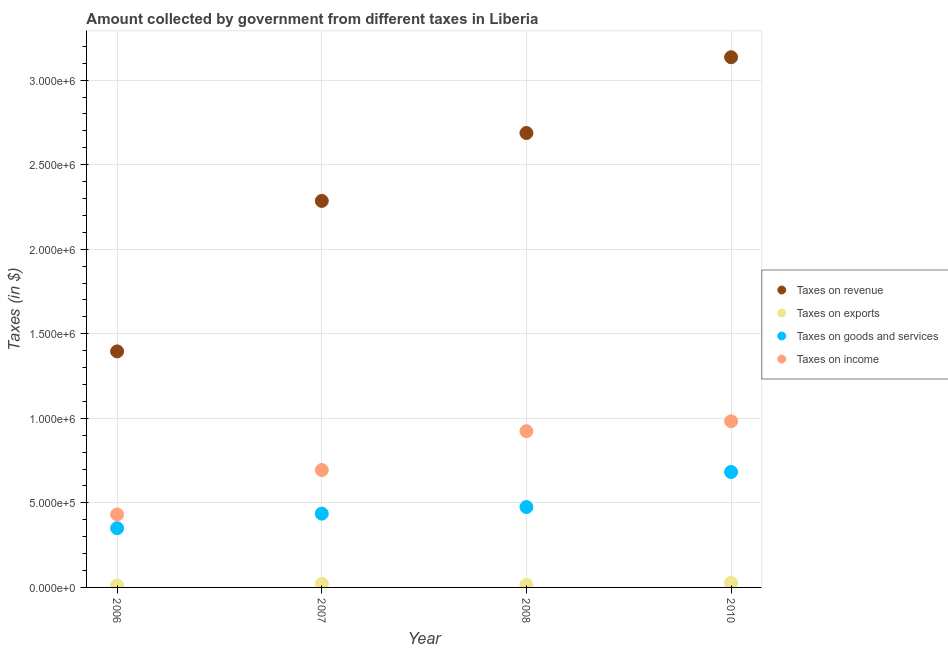How many different coloured dotlines are there?
Give a very brief answer. 4. What is the amount collected as tax on income in 2010?
Offer a terse response. 9.83e+05. Across all years, what is the maximum amount collected as tax on goods?
Provide a succinct answer. 6.83e+05. Across all years, what is the minimum amount collected as tax on revenue?
Give a very brief answer. 1.40e+06. In which year was the amount collected as tax on revenue maximum?
Offer a terse response. 2010. What is the total amount collected as tax on exports in the graph?
Your answer should be very brief. 7.47e+04. What is the difference between the amount collected as tax on income in 2007 and that in 2010?
Offer a very short reply. -2.88e+05. What is the difference between the amount collected as tax on goods in 2010 and the amount collected as tax on revenue in 2006?
Offer a terse response. -7.13e+05. What is the average amount collected as tax on income per year?
Offer a terse response. 7.58e+05. In the year 2010, what is the difference between the amount collected as tax on income and amount collected as tax on revenue?
Keep it short and to the point. -2.15e+06. What is the ratio of the amount collected as tax on exports in 2006 to that in 2010?
Keep it short and to the point. 0.44. Is the amount collected as tax on income in 2008 less than that in 2010?
Make the answer very short. Yes. What is the difference between the highest and the second highest amount collected as tax on exports?
Offer a very short reply. 5566.22. What is the difference between the highest and the lowest amount collected as tax on exports?
Your answer should be very brief. 1.50e+04. In how many years, is the amount collected as tax on goods greater than the average amount collected as tax on goods taken over all years?
Give a very brief answer. 1. Is it the case that in every year, the sum of the amount collected as tax on income and amount collected as tax on exports is greater than the sum of amount collected as tax on goods and amount collected as tax on revenue?
Provide a short and direct response. No. Is it the case that in every year, the sum of the amount collected as tax on revenue and amount collected as tax on exports is greater than the amount collected as tax on goods?
Your response must be concise. Yes. Is the amount collected as tax on income strictly less than the amount collected as tax on exports over the years?
Offer a terse response. No. How many dotlines are there?
Provide a succinct answer. 4. Are the values on the major ticks of Y-axis written in scientific E-notation?
Provide a short and direct response. Yes. Does the graph contain any zero values?
Your response must be concise. No. Does the graph contain grids?
Offer a very short reply. Yes. How many legend labels are there?
Offer a terse response. 4. How are the legend labels stacked?
Keep it short and to the point. Vertical. What is the title of the graph?
Offer a very short reply. Amount collected by government from different taxes in Liberia. What is the label or title of the Y-axis?
Offer a terse response. Taxes (in $). What is the Taxes (in $) of Taxes on revenue in 2006?
Ensure brevity in your answer.  1.40e+06. What is the Taxes (in $) of Taxes on exports in 2006?
Keep it short and to the point. 1.16e+04. What is the Taxes (in $) of Taxes on goods and services in 2006?
Your answer should be compact. 3.50e+05. What is the Taxes (in $) in Taxes on income in 2006?
Give a very brief answer. 4.32e+05. What is the Taxes (in $) in Taxes on revenue in 2007?
Offer a terse response. 2.29e+06. What is the Taxes (in $) in Taxes on exports in 2007?
Make the answer very short. 2.11e+04. What is the Taxes (in $) of Taxes on goods and services in 2007?
Provide a succinct answer. 4.36e+05. What is the Taxes (in $) in Taxes on income in 2007?
Your answer should be compact. 6.94e+05. What is the Taxes (in $) of Taxes on revenue in 2008?
Provide a short and direct response. 2.69e+06. What is the Taxes (in $) in Taxes on exports in 2008?
Ensure brevity in your answer.  1.54e+04. What is the Taxes (in $) of Taxes on goods and services in 2008?
Offer a very short reply. 4.75e+05. What is the Taxes (in $) of Taxes on income in 2008?
Your answer should be very brief. 9.24e+05. What is the Taxes (in $) in Taxes on revenue in 2010?
Offer a very short reply. 3.14e+06. What is the Taxes (in $) in Taxes on exports in 2010?
Ensure brevity in your answer.  2.67e+04. What is the Taxes (in $) of Taxes on goods and services in 2010?
Provide a short and direct response. 6.83e+05. What is the Taxes (in $) of Taxes on income in 2010?
Provide a succinct answer. 9.83e+05. Across all years, what is the maximum Taxes (in $) of Taxes on revenue?
Your answer should be very brief. 3.14e+06. Across all years, what is the maximum Taxes (in $) in Taxes on exports?
Provide a short and direct response. 2.67e+04. Across all years, what is the maximum Taxes (in $) in Taxes on goods and services?
Provide a short and direct response. 6.83e+05. Across all years, what is the maximum Taxes (in $) of Taxes on income?
Your response must be concise. 9.83e+05. Across all years, what is the minimum Taxes (in $) of Taxes on revenue?
Offer a terse response. 1.40e+06. Across all years, what is the minimum Taxes (in $) in Taxes on exports?
Your answer should be very brief. 1.16e+04. Across all years, what is the minimum Taxes (in $) of Taxes on goods and services?
Your answer should be compact. 3.50e+05. Across all years, what is the minimum Taxes (in $) in Taxes on income?
Your answer should be very brief. 4.32e+05. What is the total Taxes (in $) in Taxes on revenue in the graph?
Keep it short and to the point. 9.50e+06. What is the total Taxes (in $) in Taxes on exports in the graph?
Your answer should be compact. 7.47e+04. What is the total Taxes (in $) of Taxes on goods and services in the graph?
Offer a very short reply. 1.94e+06. What is the total Taxes (in $) of Taxes on income in the graph?
Your answer should be very brief. 3.03e+06. What is the difference between the Taxes (in $) in Taxes on revenue in 2006 and that in 2007?
Provide a succinct answer. -8.90e+05. What is the difference between the Taxes (in $) in Taxes on exports in 2006 and that in 2007?
Your response must be concise. -9442.48. What is the difference between the Taxes (in $) in Taxes on goods and services in 2006 and that in 2007?
Provide a short and direct response. -8.60e+04. What is the difference between the Taxes (in $) of Taxes on income in 2006 and that in 2007?
Make the answer very short. -2.63e+05. What is the difference between the Taxes (in $) in Taxes on revenue in 2006 and that in 2008?
Your answer should be very brief. -1.29e+06. What is the difference between the Taxes (in $) of Taxes on exports in 2006 and that in 2008?
Keep it short and to the point. -3711.06. What is the difference between the Taxes (in $) in Taxes on goods and services in 2006 and that in 2008?
Your response must be concise. -1.25e+05. What is the difference between the Taxes (in $) of Taxes on income in 2006 and that in 2008?
Offer a terse response. -4.93e+05. What is the difference between the Taxes (in $) in Taxes on revenue in 2006 and that in 2010?
Your answer should be compact. -1.74e+06. What is the difference between the Taxes (in $) of Taxes on exports in 2006 and that in 2010?
Offer a terse response. -1.50e+04. What is the difference between the Taxes (in $) in Taxes on goods and services in 2006 and that in 2010?
Ensure brevity in your answer.  -3.32e+05. What is the difference between the Taxes (in $) of Taxes on income in 2006 and that in 2010?
Keep it short and to the point. -5.51e+05. What is the difference between the Taxes (in $) of Taxes on revenue in 2007 and that in 2008?
Your response must be concise. -4.02e+05. What is the difference between the Taxes (in $) of Taxes on exports in 2007 and that in 2008?
Provide a short and direct response. 5731.42. What is the difference between the Taxes (in $) of Taxes on goods and services in 2007 and that in 2008?
Provide a succinct answer. -3.91e+04. What is the difference between the Taxes (in $) of Taxes on income in 2007 and that in 2008?
Make the answer very short. -2.30e+05. What is the difference between the Taxes (in $) in Taxes on revenue in 2007 and that in 2010?
Offer a terse response. -8.50e+05. What is the difference between the Taxes (in $) in Taxes on exports in 2007 and that in 2010?
Your response must be concise. -5566.22. What is the difference between the Taxes (in $) of Taxes on goods and services in 2007 and that in 2010?
Your answer should be compact. -2.46e+05. What is the difference between the Taxes (in $) in Taxes on income in 2007 and that in 2010?
Make the answer very short. -2.88e+05. What is the difference between the Taxes (in $) in Taxes on revenue in 2008 and that in 2010?
Provide a succinct answer. -4.48e+05. What is the difference between the Taxes (in $) in Taxes on exports in 2008 and that in 2010?
Your answer should be compact. -1.13e+04. What is the difference between the Taxes (in $) in Taxes on goods and services in 2008 and that in 2010?
Make the answer very short. -2.07e+05. What is the difference between the Taxes (in $) in Taxes on income in 2008 and that in 2010?
Offer a very short reply. -5.85e+04. What is the difference between the Taxes (in $) of Taxes on revenue in 2006 and the Taxes (in $) of Taxes on exports in 2007?
Give a very brief answer. 1.37e+06. What is the difference between the Taxes (in $) of Taxes on revenue in 2006 and the Taxes (in $) of Taxes on goods and services in 2007?
Your answer should be compact. 9.60e+05. What is the difference between the Taxes (in $) of Taxes on revenue in 2006 and the Taxes (in $) of Taxes on income in 2007?
Make the answer very short. 7.01e+05. What is the difference between the Taxes (in $) of Taxes on exports in 2006 and the Taxes (in $) of Taxes on goods and services in 2007?
Provide a succinct answer. -4.25e+05. What is the difference between the Taxes (in $) of Taxes on exports in 2006 and the Taxes (in $) of Taxes on income in 2007?
Provide a succinct answer. -6.83e+05. What is the difference between the Taxes (in $) of Taxes on goods and services in 2006 and the Taxes (in $) of Taxes on income in 2007?
Ensure brevity in your answer.  -3.44e+05. What is the difference between the Taxes (in $) in Taxes on revenue in 2006 and the Taxes (in $) in Taxes on exports in 2008?
Offer a very short reply. 1.38e+06. What is the difference between the Taxes (in $) of Taxes on revenue in 2006 and the Taxes (in $) of Taxes on goods and services in 2008?
Ensure brevity in your answer.  9.20e+05. What is the difference between the Taxes (in $) in Taxes on revenue in 2006 and the Taxes (in $) in Taxes on income in 2008?
Offer a terse response. 4.72e+05. What is the difference between the Taxes (in $) of Taxes on exports in 2006 and the Taxes (in $) of Taxes on goods and services in 2008?
Give a very brief answer. -4.64e+05. What is the difference between the Taxes (in $) in Taxes on exports in 2006 and the Taxes (in $) in Taxes on income in 2008?
Offer a very short reply. -9.12e+05. What is the difference between the Taxes (in $) of Taxes on goods and services in 2006 and the Taxes (in $) of Taxes on income in 2008?
Ensure brevity in your answer.  -5.74e+05. What is the difference between the Taxes (in $) of Taxes on revenue in 2006 and the Taxes (in $) of Taxes on exports in 2010?
Provide a succinct answer. 1.37e+06. What is the difference between the Taxes (in $) in Taxes on revenue in 2006 and the Taxes (in $) in Taxes on goods and services in 2010?
Your answer should be compact. 7.13e+05. What is the difference between the Taxes (in $) in Taxes on revenue in 2006 and the Taxes (in $) in Taxes on income in 2010?
Your answer should be very brief. 4.13e+05. What is the difference between the Taxes (in $) of Taxes on exports in 2006 and the Taxes (in $) of Taxes on goods and services in 2010?
Offer a very short reply. -6.71e+05. What is the difference between the Taxes (in $) of Taxes on exports in 2006 and the Taxes (in $) of Taxes on income in 2010?
Your response must be concise. -9.71e+05. What is the difference between the Taxes (in $) of Taxes on goods and services in 2006 and the Taxes (in $) of Taxes on income in 2010?
Ensure brevity in your answer.  -6.32e+05. What is the difference between the Taxes (in $) of Taxes on revenue in 2007 and the Taxes (in $) of Taxes on exports in 2008?
Make the answer very short. 2.27e+06. What is the difference between the Taxes (in $) in Taxes on revenue in 2007 and the Taxes (in $) in Taxes on goods and services in 2008?
Offer a terse response. 1.81e+06. What is the difference between the Taxes (in $) in Taxes on revenue in 2007 and the Taxes (in $) in Taxes on income in 2008?
Your answer should be compact. 1.36e+06. What is the difference between the Taxes (in $) in Taxes on exports in 2007 and the Taxes (in $) in Taxes on goods and services in 2008?
Give a very brief answer. -4.54e+05. What is the difference between the Taxes (in $) in Taxes on exports in 2007 and the Taxes (in $) in Taxes on income in 2008?
Your answer should be very brief. -9.03e+05. What is the difference between the Taxes (in $) in Taxes on goods and services in 2007 and the Taxes (in $) in Taxes on income in 2008?
Give a very brief answer. -4.88e+05. What is the difference between the Taxes (in $) of Taxes on revenue in 2007 and the Taxes (in $) of Taxes on exports in 2010?
Your response must be concise. 2.26e+06. What is the difference between the Taxes (in $) in Taxes on revenue in 2007 and the Taxes (in $) in Taxes on goods and services in 2010?
Your answer should be compact. 1.60e+06. What is the difference between the Taxes (in $) of Taxes on revenue in 2007 and the Taxes (in $) of Taxes on income in 2010?
Provide a succinct answer. 1.30e+06. What is the difference between the Taxes (in $) in Taxes on exports in 2007 and the Taxes (in $) in Taxes on goods and services in 2010?
Ensure brevity in your answer.  -6.62e+05. What is the difference between the Taxes (in $) of Taxes on exports in 2007 and the Taxes (in $) of Taxes on income in 2010?
Offer a very short reply. -9.62e+05. What is the difference between the Taxes (in $) of Taxes on goods and services in 2007 and the Taxes (in $) of Taxes on income in 2010?
Ensure brevity in your answer.  -5.46e+05. What is the difference between the Taxes (in $) in Taxes on revenue in 2008 and the Taxes (in $) in Taxes on exports in 2010?
Provide a succinct answer. 2.66e+06. What is the difference between the Taxes (in $) of Taxes on revenue in 2008 and the Taxes (in $) of Taxes on goods and services in 2010?
Offer a very short reply. 2.00e+06. What is the difference between the Taxes (in $) of Taxes on revenue in 2008 and the Taxes (in $) of Taxes on income in 2010?
Provide a short and direct response. 1.70e+06. What is the difference between the Taxes (in $) in Taxes on exports in 2008 and the Taxes (in $) in Taxes on goods and services in 2010?
Provide a succinct answer. -6.67e+05. What is the difference between the Taxes (in $) of Taxes on exports in 2008 and the Taxes (in $) of Taxes on income in 2010?
Ensure brevity in your answer.  -9.67e+05. What is the difference between the Taxes (in $) of Taxes on goods and services in 2008 and the Taxes (in $) of Taxes on income in 2010?
Your answer should be compact. -5.07e+05. What is the average Taxes (in $) of Taxes on revenue per year?
Keep it short and to the point. 2.38e+06. What is the average Taxes (in $) of Taxes on exports per year?
Give a very brief answer. 1.87e+04. What is the average Taxes (in $) of Taxes on goods and services per year?
Provide a succinct answer. 4.86e+05. What is the average Taxes (in $) in Taxes on income per year?
Give a very brief answer. 7.58e+05. In the year 2006, what is the difference between the Taxes (in $) in Taxes on revenue and Taxes (in $) in Taxes on exports?
Give a very brief answer. 1.38e+06. In the year 2006, what is the difference between the Taxes (in $) in Taxes on revenue and Taxes (in $) in Taxes on goods and services?
Provide a succinct answer. 1.05e+06. In the year 2006, what is the difference between the Taxes (in $) in Taxes on revenue and Taxes (in $) in Taxes on income?
Keep it short and to the point. 9.64e+05. In the year 2006, what is the difference between the Taxes (in $) in Taxes on exports and Taxes (in $) in Taxes on goods and services?
Make the answer very short. -3.39e+05. In the year 2006, what is the difference between the Taxes (in $) in Taxes on exports and Taxes (in $) in Taxes on income?
Make the answer very short. -4.20e+05. In the year 2006, what is the difference between the Taxes (in $) of Taxes on goods and services and Taxes (in $) of Taxes on income?
Your answer should be very brief. -8.13e+04. In the year 2007, what is the difference between the Taxes (in $) in Taxes on revenue and Taxes (in $) in Taxes on exports?
Offer a very short reply. 2.26e+06. In the year 2007, what is the difference between the Taxes (in $) in Taxes on revenue and Taxes (in $) in Taxes on goods and services?
Keep it short and to the point. 1.85e+06. In the year 2007, what is the difference between the Taxes (in $) in Taxes on revenue and Taxes (in $) in Taxes on income?
Your response must be concise. 1.59e+06. In the year 2007, what is the difference between the Taxes (in $) of Taxes on exports and Taxes (in $) of Taxes on goods and services?
Your answer should be very brief. -4.15e+05. In the year 2007, what is the difference between the Taxes (in $) of Taxes on exports and Taxes (in $) of Taxes on income?
Offer a very short reply. -6.73e+05. In the year 2007, what is the difference between the Taxes (in $) in Taxes on goods and services and Taxes (in $) in Taxes on income?
Keep it short and to the point. -2.58e+05. In the year 2008, what is the difference between the Taxes (in $) of Taxes on revenue and Taxes (in $) of Taxes on exports?
Provide a short and direct response. 2.67e+06. In the year 2008, what is the difference between the Taxes (in $) in Taxes on revenue and Taxes (in $) in Taxes on goods and services?
Give a very brief answer. 2.21e+06. In the year 2008, what is the difference between the Taxes (in $) of Taxes on revenue and Taxes (in $) of Taxes on income?
Ensure brevity in your answer.  1.76e+06. In the year 2008, what is the difference between the Taxes (in $) of Taxes on exports and Taxes (in $) of Taxes on goods and services?
Your response must be concise. -4.60e+05. In the year 2008, what is the difference between the Taxes (in $) of Taxes on exports and Taxes (in $) of Taxes on income?
Your response must be concise. -9.09e+05. In the year 2008, what is the difference between the Taxes (in $) in Taxes on goods and services and Taxes (in $) in Taxes on income?
Keep it short and to the point. -4.49e+05. In the year 2010, what is the difference between the Taxes (in $) of Taxes on revenue and Taxes (in $) of Taxes on exports?
Keep it short and to the point. 3.11e+06. In the year 2010, what is the difference between the Taxes (in $) in Taxes on revenue and Taxes (in $) in Taxes on goods and services?
Provide a short and direct response. 2.45e+06. In the year 2010, what is the difference between the Taxes (in $) in Taxes on revenue and Taxes (in $) in Taxes on income?
Provide a short and direct response. 2.15e+06. In the year 2010, what is the difference between the Taxes (in $) of Taxes on exports and Taxes (in $) of Taxes on goods and services?
Give a very brief answer. -6.56e+05. In the year 2010, what is the difference between the Taxes (in $) of Taxes on exports and Taxes (in $) of Taxes on income?
Your answer should be compact. -9.56e+05. In the year 2010, what is the difference between the Taxes (in $) of Taxes on goods and services and Taxes (in $) of Taxes on income?
Give a very brief answer. -3.00e+05. What is the ratio of the Taxes (in $) in Taxes on revenue in 2006 to that in 2007?
Your response must be concise. 0.61. What is the ratio of the Taxes (in $) of Taxes on exports in 2006 to that in 2007?
Give a very brief answer. 0.55. What is the ratio of the Taxes (in $) of Taxes on goods and services in 2006 to that in 2007?
Ensure brevity in your answer.  0.8. What is the ratio of the Taxes (in $) of Taxes on income in 2006 to that in 2007?
Keep it short and to the point. 0.62. What is the ratio of the Taxes (in $) of Taxes on revenue in 2006 to that in 2008?
Provide a short and direct response. 0.52. What is the ratio of the Taxes (in $) of Taxes on exports in 2006 to that in 2008?
Make the answer very short. 0.76. What is the ratio of the Taxes (in $) in Taxes on goods and services in 2006 to that in 2008?
Offer a terse response. 0.74. What is the ratio of the Taxes (in $) of Taxes on income in 2006 to that in 2008?
Your response must be concise. 0.47. What is the ratio of the Taxes (in $) in Taxes on revenue in 2006 to that in 2010?
Offer a very short reply. 0.45. What is the ratio of the Taxes (in $) of Taxes on exports in 2006 to that in 2010?
Keep it short and to the point. 0.44. What is the ratio of the Taxes (in $) of Taxes on goods and services in 2006 to that in 2010?
Ensure brevity in your answer.  0.51. What is the ratio of the Taxes (in $) in Taxes on income in 2006 to that in 2010?
Offer a very short reply. 0.44. What is the ratio of the Taxes (in $) in Taxes on revenue in 2007 to that in 2008?
Make the answer very short. 0.85. What is the ratio of the Taxes (in $) of Taxes on exports in 2007 to that in 2008?
Offer a very short reply. 1.37. What is the ratio of the Taxes (in $) of Taxes on goods and services in 2007 to that in 2008?
Provide a succinct answer. 0.92. What is the ratio of the Taxes (in $) of Taxes on income in 2007 to that in 2008?
Provide a succinct answer. 0.75. What is the ratio of the Taxes (in $) of Taxes on revenue in 2007 to that in 2010?
Offer a terse response. 0.73. What is the ratio of the Taxes (in $) in Taxes on exports in 2007 to that in 2010?
Make the answer very short. 0.79. What is the ratio of the Taxes (in $) of Taxes on goods and services in 2007 to that in 2010?
Your answer should be very brief. 0.64. What is the ratio of the Taxes (in $) in Taxes on income in 2007 to that in 2010?
Offer a very short reply. 0.71. What is the ratio of the Taxes (in $) in Taxes on revenue in 2008 to that in 2010?
Give a very brief answer. 0.86. What is the ratio of the Taxes (in $) in Taxes on exports in 2008 to that in 2010?
Your response must be concise. 0.58. What is the ratio of the Taxes (in $) in Taxes on goods and services in 2008 to that in 2010?
Provide a succinct answer. 0.7. What is the ratio of the Taxes (in $) of Taxes on income in 2008 to that in 2010?
Your response must be concise. 0.94. What is the difference between the highest and the second highest Taxes (in $) in Taxes on revenue?
Provide a short and direct response. 4.48e+05. What is the difference between the highest and the second highest Taxes (in $) of Taxes on exports?
Your answer should be compact. 5566.22. What is the difference between the highest and the second highest Taxes (in $) in Taxes on goods and services?
Make the answer very short. 2.07e+05. What is the difference between the highest and the second highest Taxes (in $) of Taxes on income?
Your answer should be compact. 5.85e+04. What is the difference between the highest and the lowest Taxes (in $) in Taxes on revenue?
Provide a short and direct response. 1.74e+06. What is the difference between the highest and the lowest Taxes (in $) of Taxes on exports?
Your answer should be very brief. 1.50e+04. What is the difference between the highest and the lowest Taxes (in $) of Taxes on goods and services?
Offer a very short reply. 3.32e+05. What is the difference between the highest and the lowest Taxes (in $) of Taxes on income?
Your answer should be very brief. 5.51e+05. 